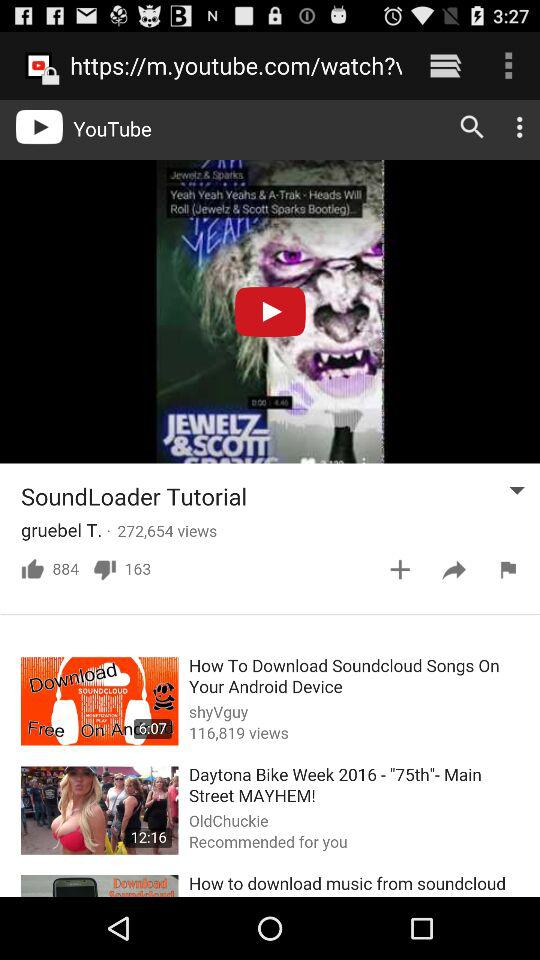What is the duration of the "Daytona Bike Week 2016 -"75th"- Main Street MAYHEM!"? The duration is 12 minutes and 16 seconds. 